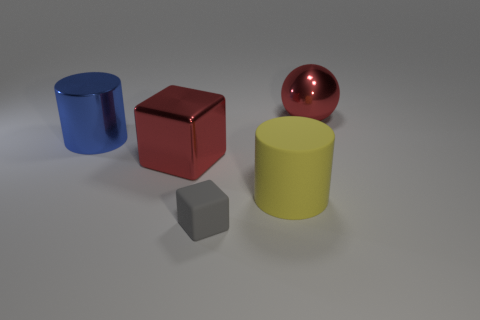Add 3 metallic spheres. How many objects exist? 8 Subtract all red blocks. How many blocks are left? 1 Subtract all cubes. How many objects are left? 3 Subtract 1 blocks. How many blocks are left? 1 Subtract all purple blocks. How many blue cylinders are left? 1 Subtract all green metal cylinders. Subtract all matte blocks. How many objects are left? 4 Add 2 small gray rubber objects. How many small gray rubber objects are left? 3 Add 5 large gray things. How many large gray things exist? 5 Subtract 1 red spheres. How many objects are left? 4 Subtract all purple blocks. Subtract all cyan cylinders. How many blocks are left? 2 